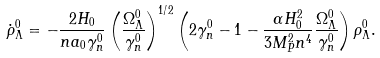<formula> <loc_0><loc_0><loc_500><loc_500>\dot { \rho } _ { \Lambda } ^ { 0 } = - \frac { 2 H _ { 0 } } { n a _ { 0 } \gamma _ { n } ^ { 0 } } \left ( { \frac { \Omega _ { \Lambda } ^ { 0 } } { \gamma _ { n } ^ { 0 } } } \right ) ^ { 1 / 2 } \left ( 2 \gamma _ { n } ^ { 0 } - 1 - \frac { \alpha H _ { 0 } ^ { 2 } } { 3 { M ^ { 2 } _ { P } } n ^ { 4 } } \frac { \Omega _ { \Lambda } ^ { 0 } } { \gamma _ { n } ^ { 0 } } \right ) \rho _ { \Lambda } ^ { 0 } .</formula> 